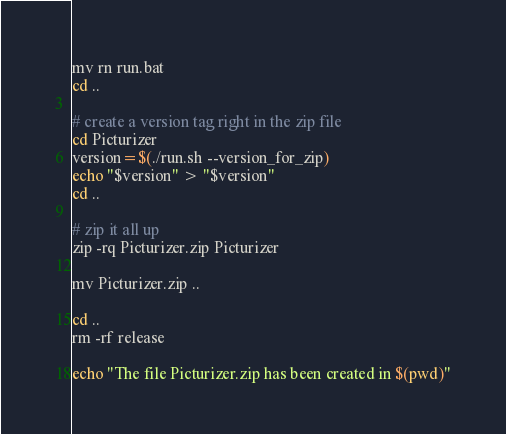<code> <loc_0><loc_0><loc_500><loc_500><_Bash_>mv rn run.bat
cd ..

# create a version tag right in the zip file
cd Picturizer
version=$(./run.sh --version_for_zip)
echo "$version" > "$version"
cd ..

# zip it all up
zip -rq Picturizer.zip Picturizer

mv Picturizer.zip ..

cd ..
rm -rf release

echo "The file Picturizer.zip has been created in $(pwd)"
</code> 